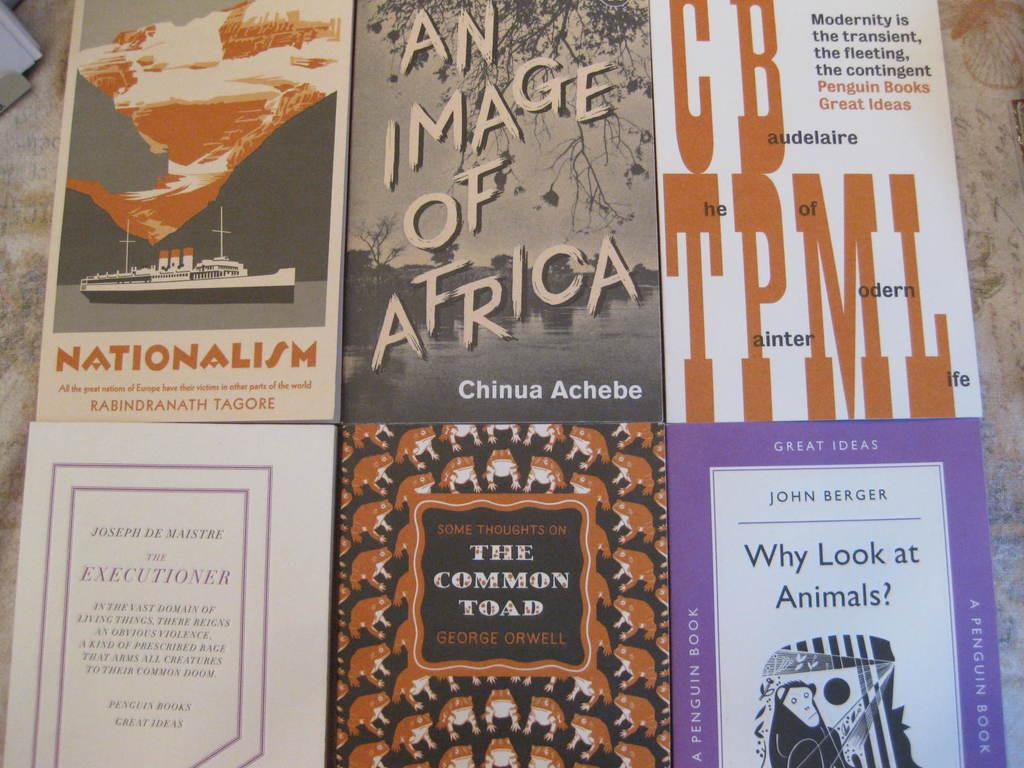<image>
Summarize the visual content of the image. Six books on table including one called An Image of Africa. 